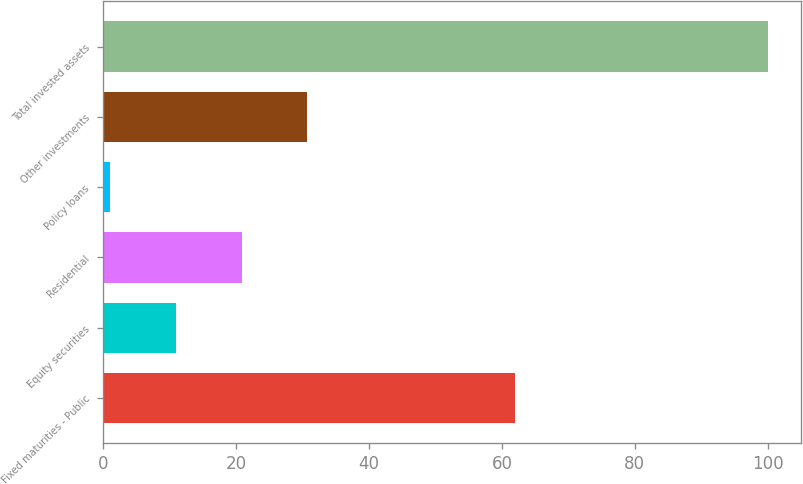Convert chart to OTSL. <chart><loc_0><loc_0><loc_500><loc_500><bar_chart><fcel>Fixed maturities - Public<fcel>Equity securities<fcel>Residential<fcel>Policy loans<fcel>Other investments<fcel>Total invested assets<nl><fcel>62<fcel>10.9<fcel>20.8<fcel>1<fcel>30.7<fcel>100<nl></chart> 